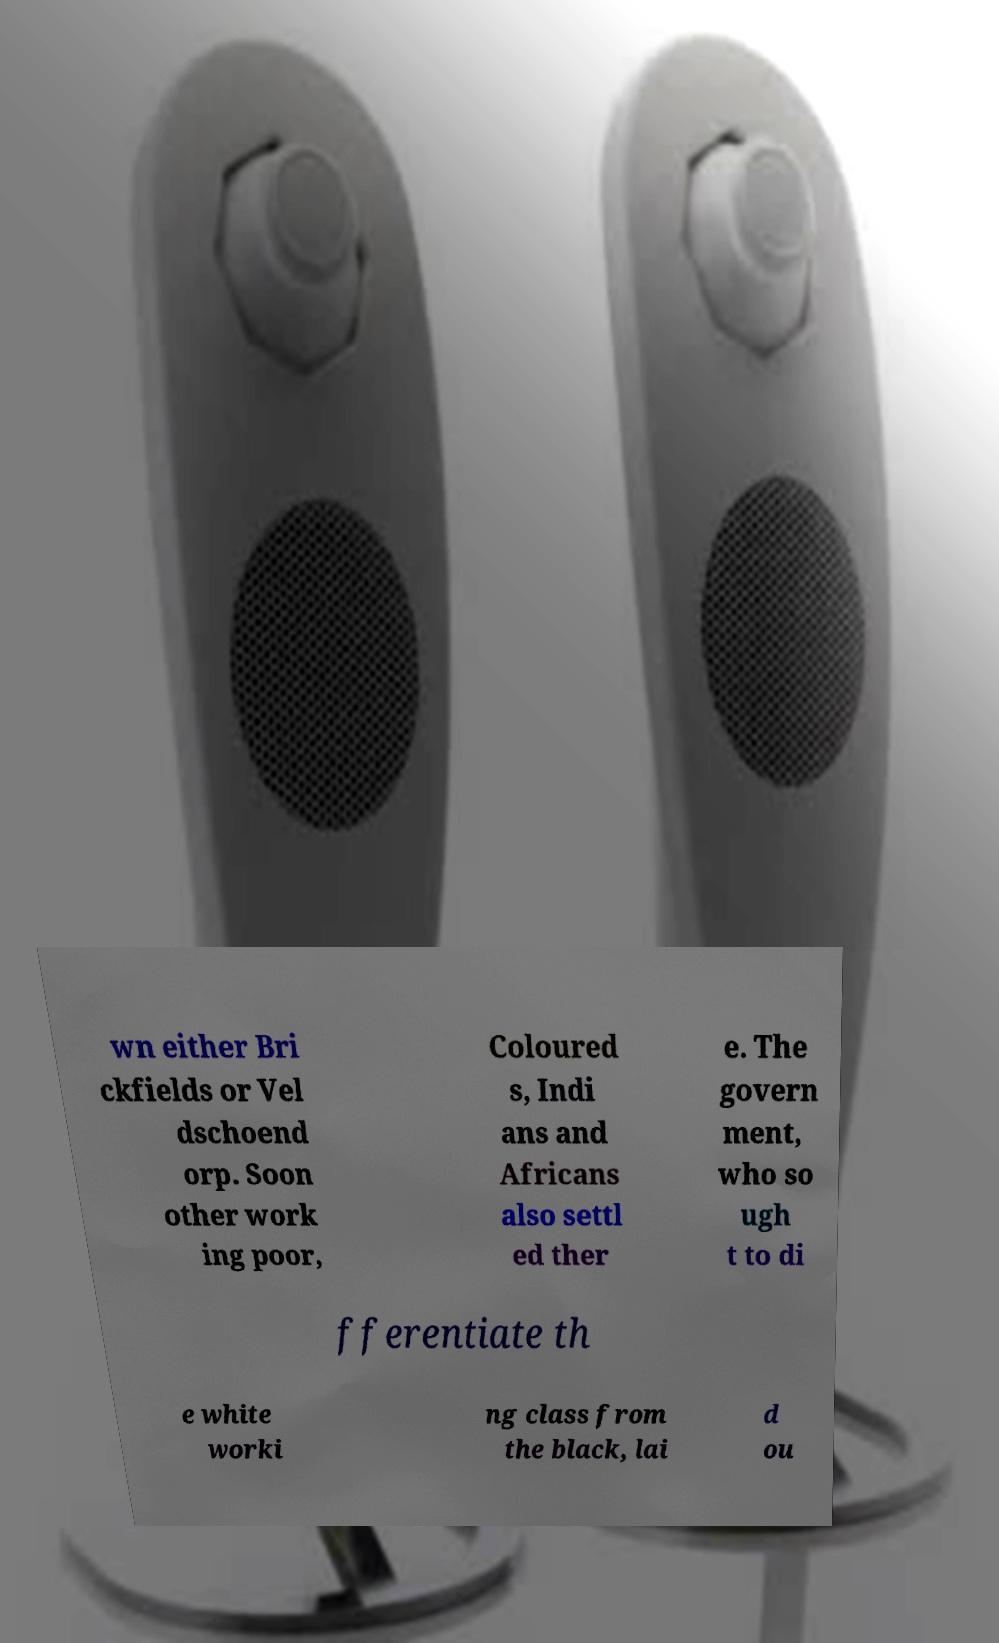Could you assist in decoding the text presented in this image and type it out clearly? wn either Bri ckfields or Vel dschoend orp. Soon other work ing poor, Coloured s, Indi ans and Africans also settl ed ther e. The govern ment, who so ugh t to di fferentiate th e white worki ng class from the black, lai d ou 